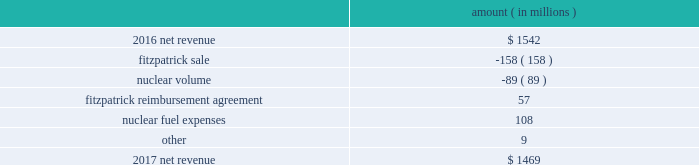The regulatory credit resulting from reduction of the federal corporate income tax rate variance is due to the reduction of the vidalia purchased power agreement regulatory liability by $ 30.5 million and the reduction of the louisiana act 55 financing savings obligation regulatory liabilities by $ 25 million as a result of the enactment of the tax cuts and jobs act , in december 2017 , which lowered the federal corporate income tax rate from 35% ( 35 % ) to 21% ( 21 % ) .
The effects of the tax cuts and jobs act are discussed further in note 3 to the financial statements .
The grand gulf recovery variance is primarily due to increased recovery of higher operating costs .
The louisiana act 55 financing savings obligation variance results from a regulatory charge in 2016 for tax savings to be shared with customers per an agreement approved by the lpsc .
The tax savings resulted from the 2010-2011 irs audit settlement on the treatment of the louisiana act 55 financing of storm costs for hurricane gustav and hurricane ike .
See note 3 to the financial statements for additional discussion of the settlement and benefit sharing .
The volume/weather variance is primarily due to the effect of less favorable weather on residential and commercial sales , partially offset by an increase in industrial usage .
The increase in industrial usage is primarily due to new customers in the primary metals industry and expansion projects and an increase in demand for existing customers in the chlor-alkali industry .
Entergy wholesale commodities following is an analysis of the change in net revenue comparing 2017 to 2016 .
Amount ( in millions ) .
As shown in the table above , net revenue for entergy wholesale commodities decreased by approximately $ 73 million in 2017 primarily due to the absence of net revenue from the fitzpatrick plant after it was sold to exelon in march 2017 and lower volume in the entergy wholesale commodities nuclear fleet resulting from more outage days in 2017 as compared to 2016 .
The decrease was partially offset by an increase resulting from the reimbursement agreement with exelon pursuant to which exelon reimbursed entergy for specified out-of-pocket costs associated with preparing for the refueling and operation of fitzpatrick that otherwise would have been avoided had entergy shut down fitzpatrick in january 2017 and a decrease in nuclear fuel expenses primarily related to the impairments of the indian point 2 , indian point 3 , and palisades plants and related assets .
Revenues received from exelon in 2017 under the reimbursement agreement are offset by other operation and maintenance expenses and taxes other than income taxes and had no effect on net income .
See note 14 to the financial statements for discussion of the sale of fitzpatrick , the reimbursement agreement with exelon , and the impairments and related charges .
Entergy corporation and subsidiaries management 2019s financial discussion and analysis .
What are the nuclear fuel expenses as a percentage of 2017 net revenue? 
Computations: (108 / 1469)
Answer: 0.07352. 